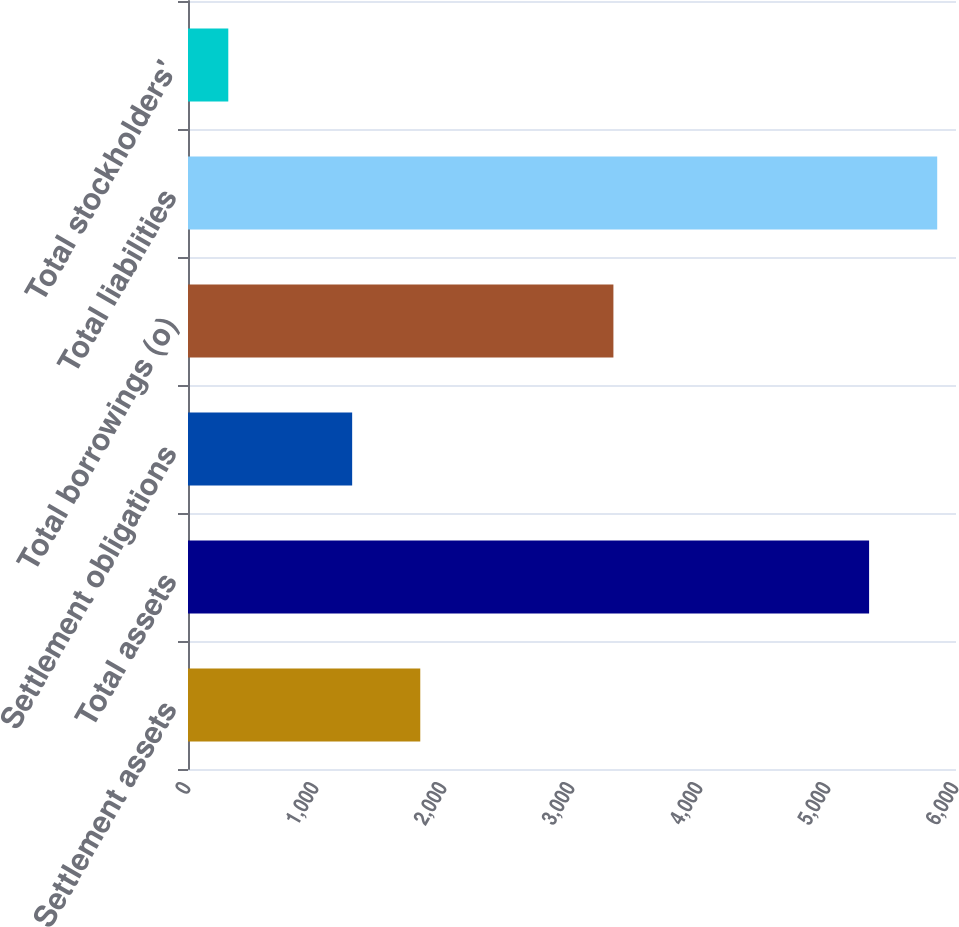Convert chart to OTSL. <chart><loc_0><loc_0><loc_500><loc_500><bar_chart><fcel>Settlement assets<fcel>Total assets<fcel>Settlement obligations<fcel>Total borrowings (o)<fcel>Total liabilities<fcel>Total stockholders'<nl><fcel>1814.61<fcel>5321.1<fcel>1282.5<fcel>3323.5<fcel>5853.21<fcel>314.8<nl></chart> 